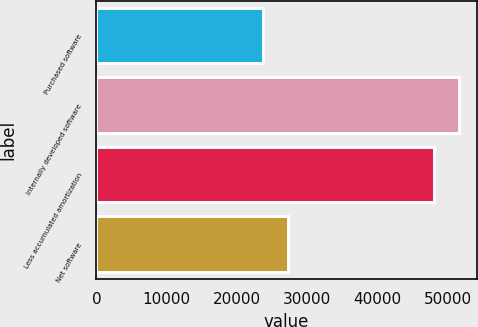<chart> <loc_0><loc_0><loc_500><loc_500><bar_chart><fcel>Purchased software<fcel>Internally developed software<fcel>Less accumulated amortization<fcel>Net software<nl><fcel>23753<fcel>51507<fcel>47957<fcel>27303<nl></chart> 